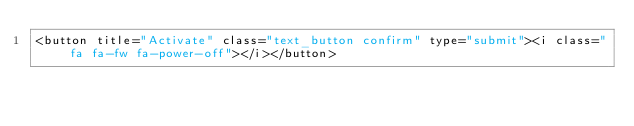<code> <loc_0><loc_0><loc_500><loc_500><_PHP_><button title="Activate" class="text_button confirm" type="submit"><i class="fa fa-fw fa-power-off"></i></button>
</code> 